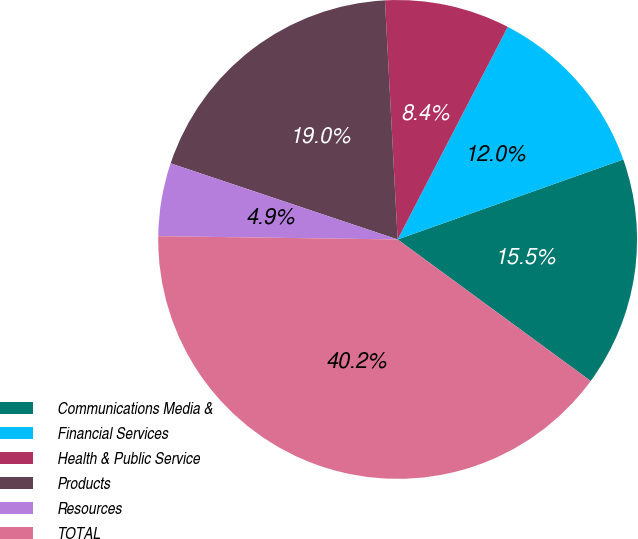<chart> <loc_0><loc_0><loc_500><loc_500><pie_chart><fcel>Communications Media &<fcel>Financial Services<fcel>Health & Public Service<fcel>Products<fcel>Resources<fcel>TOTAL<nl><fcel>15.49%<fcel>11.97%<fcel>8.45%<fcel>19.01%<fcel>4.93%<fcel>40.15%<nl></chart> 